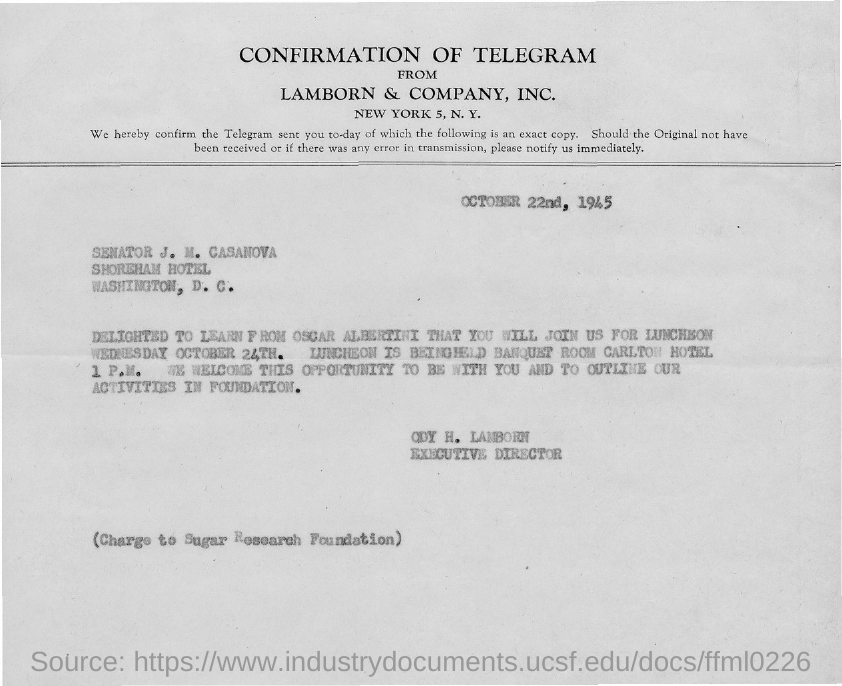What is the date on the document?
Keep it short and to the point. OCTOBER 22nd, 1945. Delighted to learn from whom?
Your answer should be compact. Oscar Albertini. What time is the Luncheon?
Ensure brevity in your answer.  1 P.M. 